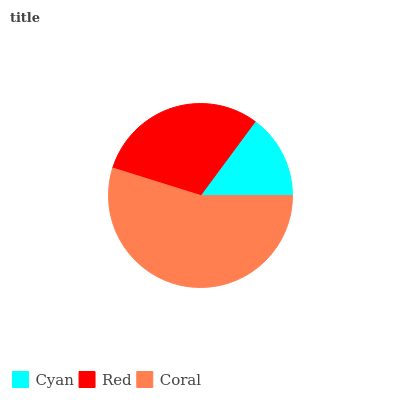Is Cyan the minimum?
Answer yes or no. Yes. Is Coral the maximum?
Answer yes or no. Yes. Is Red the minimum?
Answer yes or no. No. Is Red the maximum?
Answer yes or no. No. Is Red greater than Cyan?
Answer yes or no. Yes. Is Cyan less than Red?
Answer yes or no. Yes. Is Cyan greater than Red?
Answer yes or no. No. Is Red less than Cyan?
Answer yes or no. No. Is Red the high median?
Answer yes or no. Yes. Is Red the low median?
Answer yes or no. Yes. Is Cyan the high median?
Answer yes or no. No. Is Coral the low median?
Answer yes or no. No. 